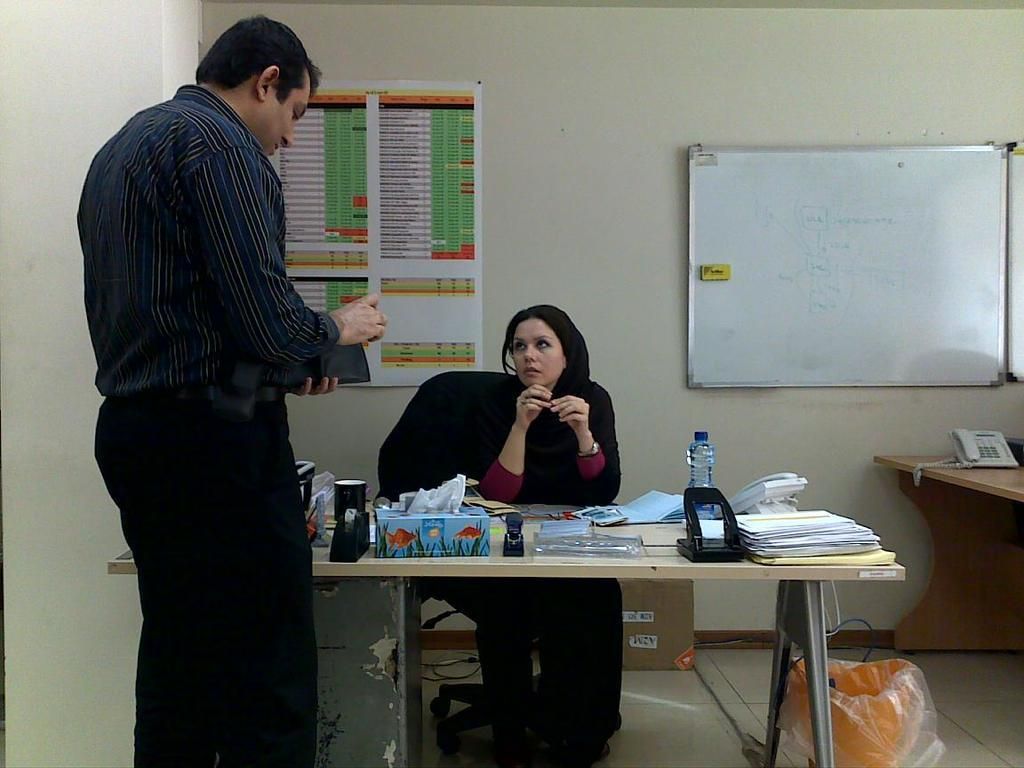What is the lady doing in the image? The lady is sitting on a chair in the image. Where is the lady positioned in relation to the table? The lady is in front of a table in the image. What can be seen on the table in the image? There are things on the table in the image. What is the man doing in the image? The man is standing in front of the table in the image. Can you hear the man whistling in the image? There is no indication of sound in the image, so it is not possible to determine if the man is whistling or not. 